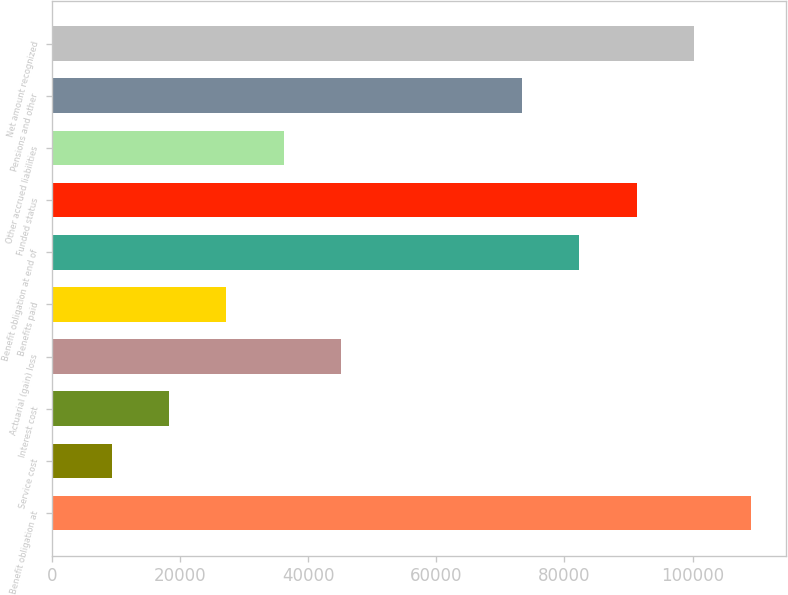<chart> <loc_0><loc_0><loc_500><loc_500><bar_chart><fcel>Benefit obligation at<fcel>Service cost<fcel>Interest cost<fcel>Actuarial (gain) loss<fcel>Benefits paid<fcel>Benefit obligation at end of<fcel>Funded status<fcel>Other accrued liabilities<fcel>Pensions and other<fcel>Net amount recognized<nl><fcel>109141<fcel>9370<fcel>18305<fcel>45110<fcel>27240<fcel>82336<fcel>91271<fcel>36175<fcel>73401<fcel>100206<nl></chart> 